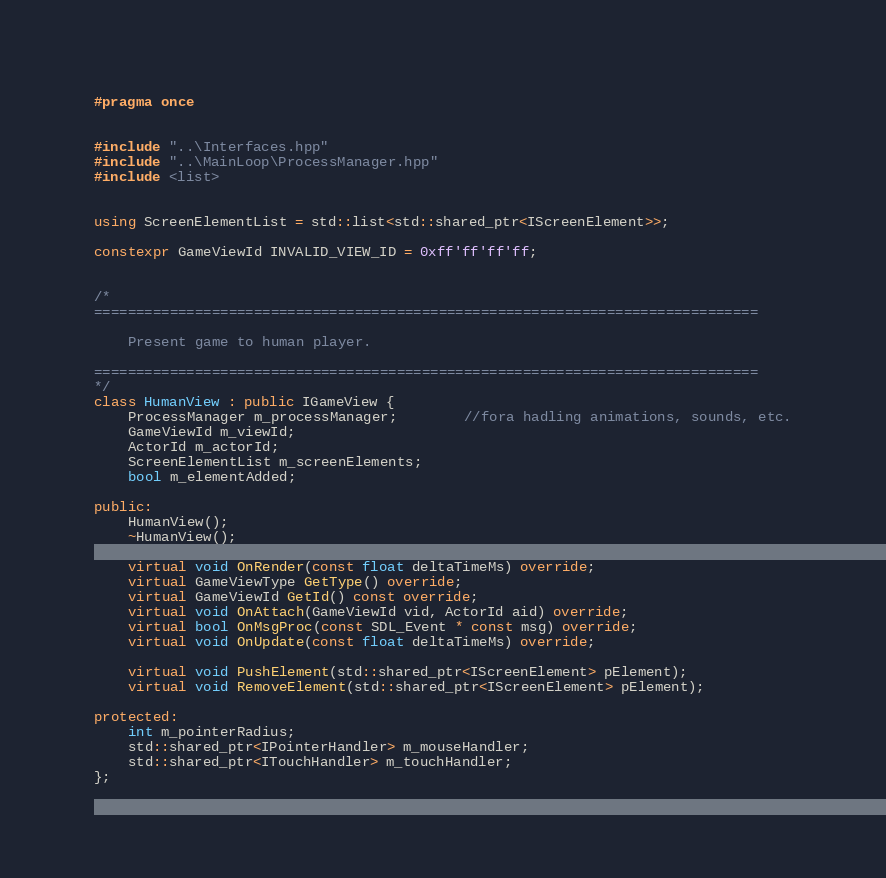<code> <loc_0><loc_0><loc_500><loc_500><_C++_>#pragma once


#include "..\Interfaces.hpp"
#include "..\MainLoop\ProcessManager.hpp"
#include <list>


using ScreenElementList = std::list<std::shared_ptr<IScreenElement>>;

constexpr GameViewId INVALID_VIEW_ID = 0xff'ff'ff'ff;


/*
===============================================================================

	Present game to human player. 

===============================================================================
*/
class HumanView : public IGameView {
	ProcessManager m_processManager;		//fora hadling animations, sounds, etc.
	GameViewId m_viewId;
	ActorId m_actorId;
	ScreenElementList m_screenElements;
	bool m_elementAdded;

public:
	HumanView();
	~HumanView();

	virtual void OnRender(const float deltaTimeMs) override;
	virtual GameViewType GetType() override;
	virtual GameViewId GetId() const override;
	virtual void OnAttach(GameViewId vid, ActorId aid) override;
	virtual bool OnMsgProc(const SDL_Event * const msg) override;
	virtual void OnUpdate(const float deltaTimeMs) override;

	virtual void PushElement(std::shared_ptr<IScreenElement> pElement);
	virtual void RemoveElement(std::shared_ptr<IScreenElement> pElement);

protected:
	int m_pointerRadius;
	std::shared_ptr<IPointerHandler> m_mouseHandler;
	std::shared_ptr<ITouchHandler> m_touchHandler;
};

</code> 